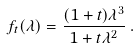Convert formula to latex. <formula><loc_0><loc_0><loc_500><loc_500>f _ { t } ( \lambda ) = \frac { ( 1 + t ) \lambda ^ { 3 } } { 1 + t \lambda ^ { 2 } } \, .</formula> 